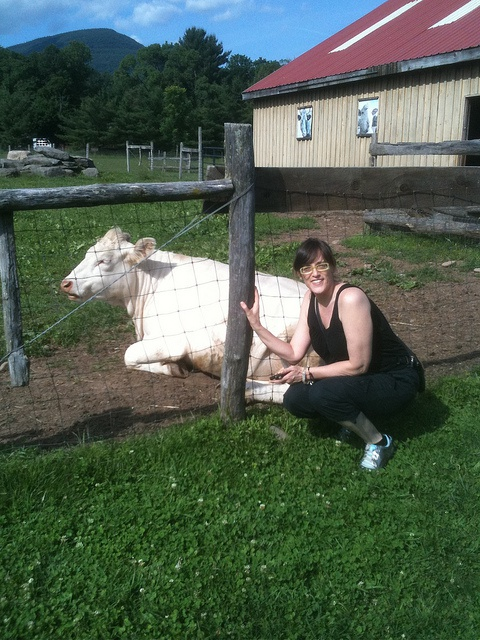Describe the objects in this image and their specific colors. I can see cow in lightblue, white, darkgray, and gray tones and people in lightblue, black, lightpink, gray, and lightgray tones in this image. 